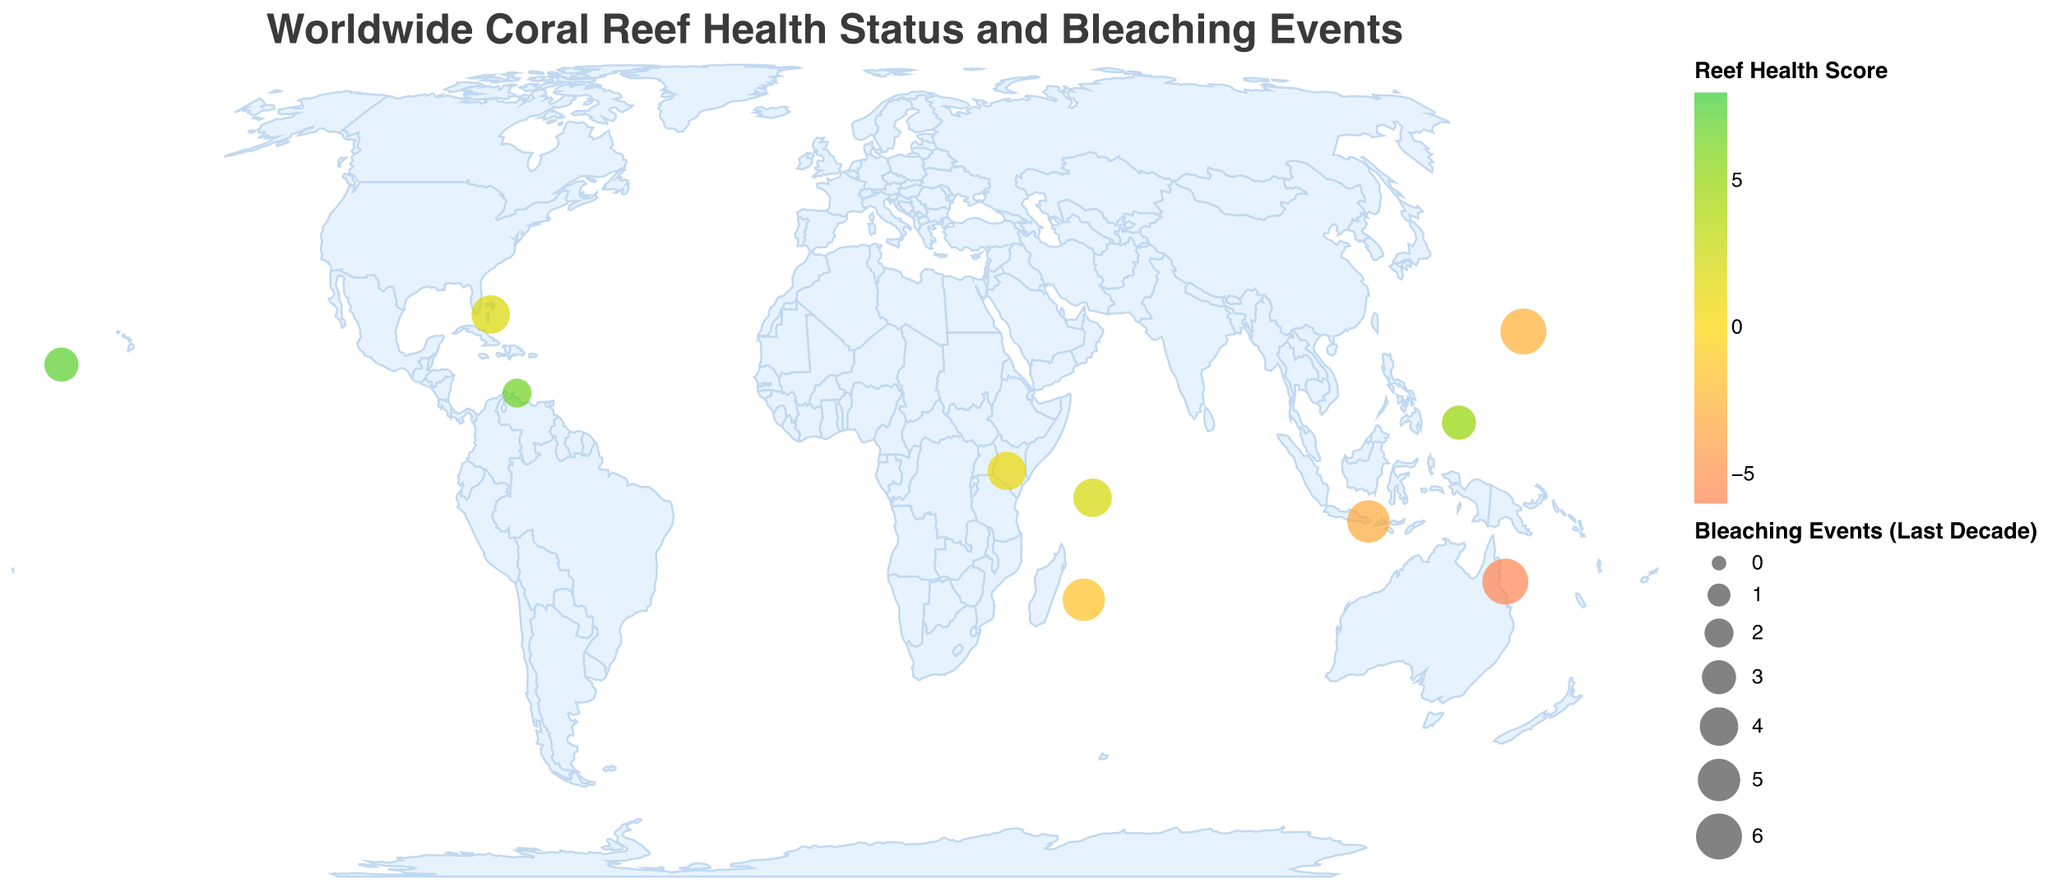What's the title of the plot? The title is usually placed at the top of the plot and indicates what the plot is about. In this case, it states the focus on coral reef health and bleaching events globally.
Answer: Worldwide Coral Reef Health Status and Bleaching Events How many bleaching events have occurred in the last decade at Palmyra Atoll? To answer this, locate Palmyra Atoll in the plot and check the number of bleaching events indicated.
Answer: 3 Which location has the highest Reef Health Score? Observe the color intensity representing the health score and match it with the tooltip data. Palmyra Atoll has the highest Reef Health Score with 7.2.
Answer: Palmyra Atoll Which location has the most bleaching events in the last decade, and how many? Look for the largest circle size in the plot, which indicates the highest number of bleaching events. Great Barrier Reef has the most bleaching events with 6 occurrences.
Answer: Great Barrier Reef, 6 Compare the Reef Health Score of Seychelles and Bahamas. Which one is healthier? Check the colors representing the Reef Health Score and refer to tooltips for exact comparisons. Seychelles has a Reef Health Score of 2.1, while Bahamas has a score of 1.8. Therefore, Seychelles is healthier.
Answer: Seychelles What is the dominant coral species in the Maldives? Identify Maldives on the map and refer to the tooltip to find the dominant coral species.
Answer: Porites cylindrica Which location has the highest average water temperature, and what is the temperature? Examine the tooltip data for each location and compare the "Avg_Water_Temp_C" values. Palau has the highest average water temperature with 29.1°C.
Answer: Palau, 29.1°C What's the sum of bleaching events in the last decade for Réunion and Okinawa? Add the bleaching events for Réunion (5) and Okinawa (6).
Answer: 11 What color indicates a poor Reef Health Score, and which location exemplifies this? Poor Reef Health Scores are shown in shades closer to orange. Great Barrier Reef has the poorest score.
Answer: Orange, Great Barrier Reef Which location has a better health score, Bali or Réunion, and by how much? Compare the Reef Health Scores. Bali has -3.2, and Réunion has -1.5. Bali's score is 1.7 units worse than Réunion's.
Answer: Réunion, 1.7 units 